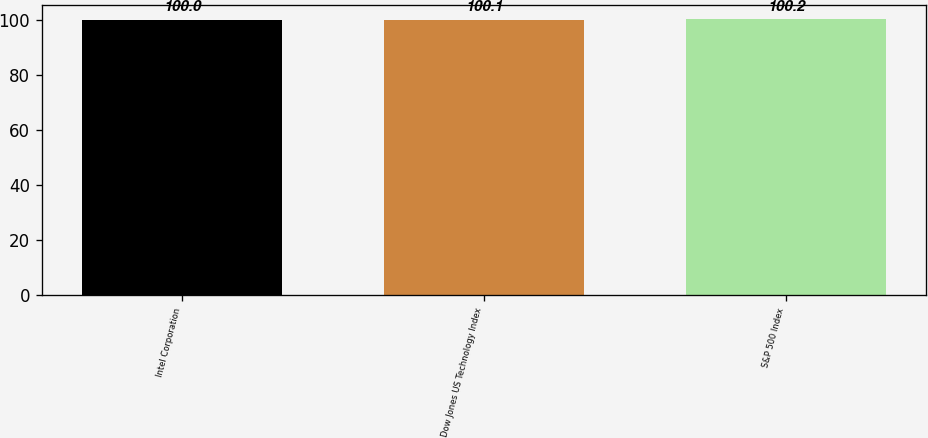Convert chart to OTSL. <chart><loc_0><loc_0><loc_500><loc_500><bar_chart><fcel>Intel Corporation<fcel>Dow Jones US Technology Index<fcel>S&P 500 Index<nl><fcel>100<fcel>100.1<fcel>100.2<nl></chart> 